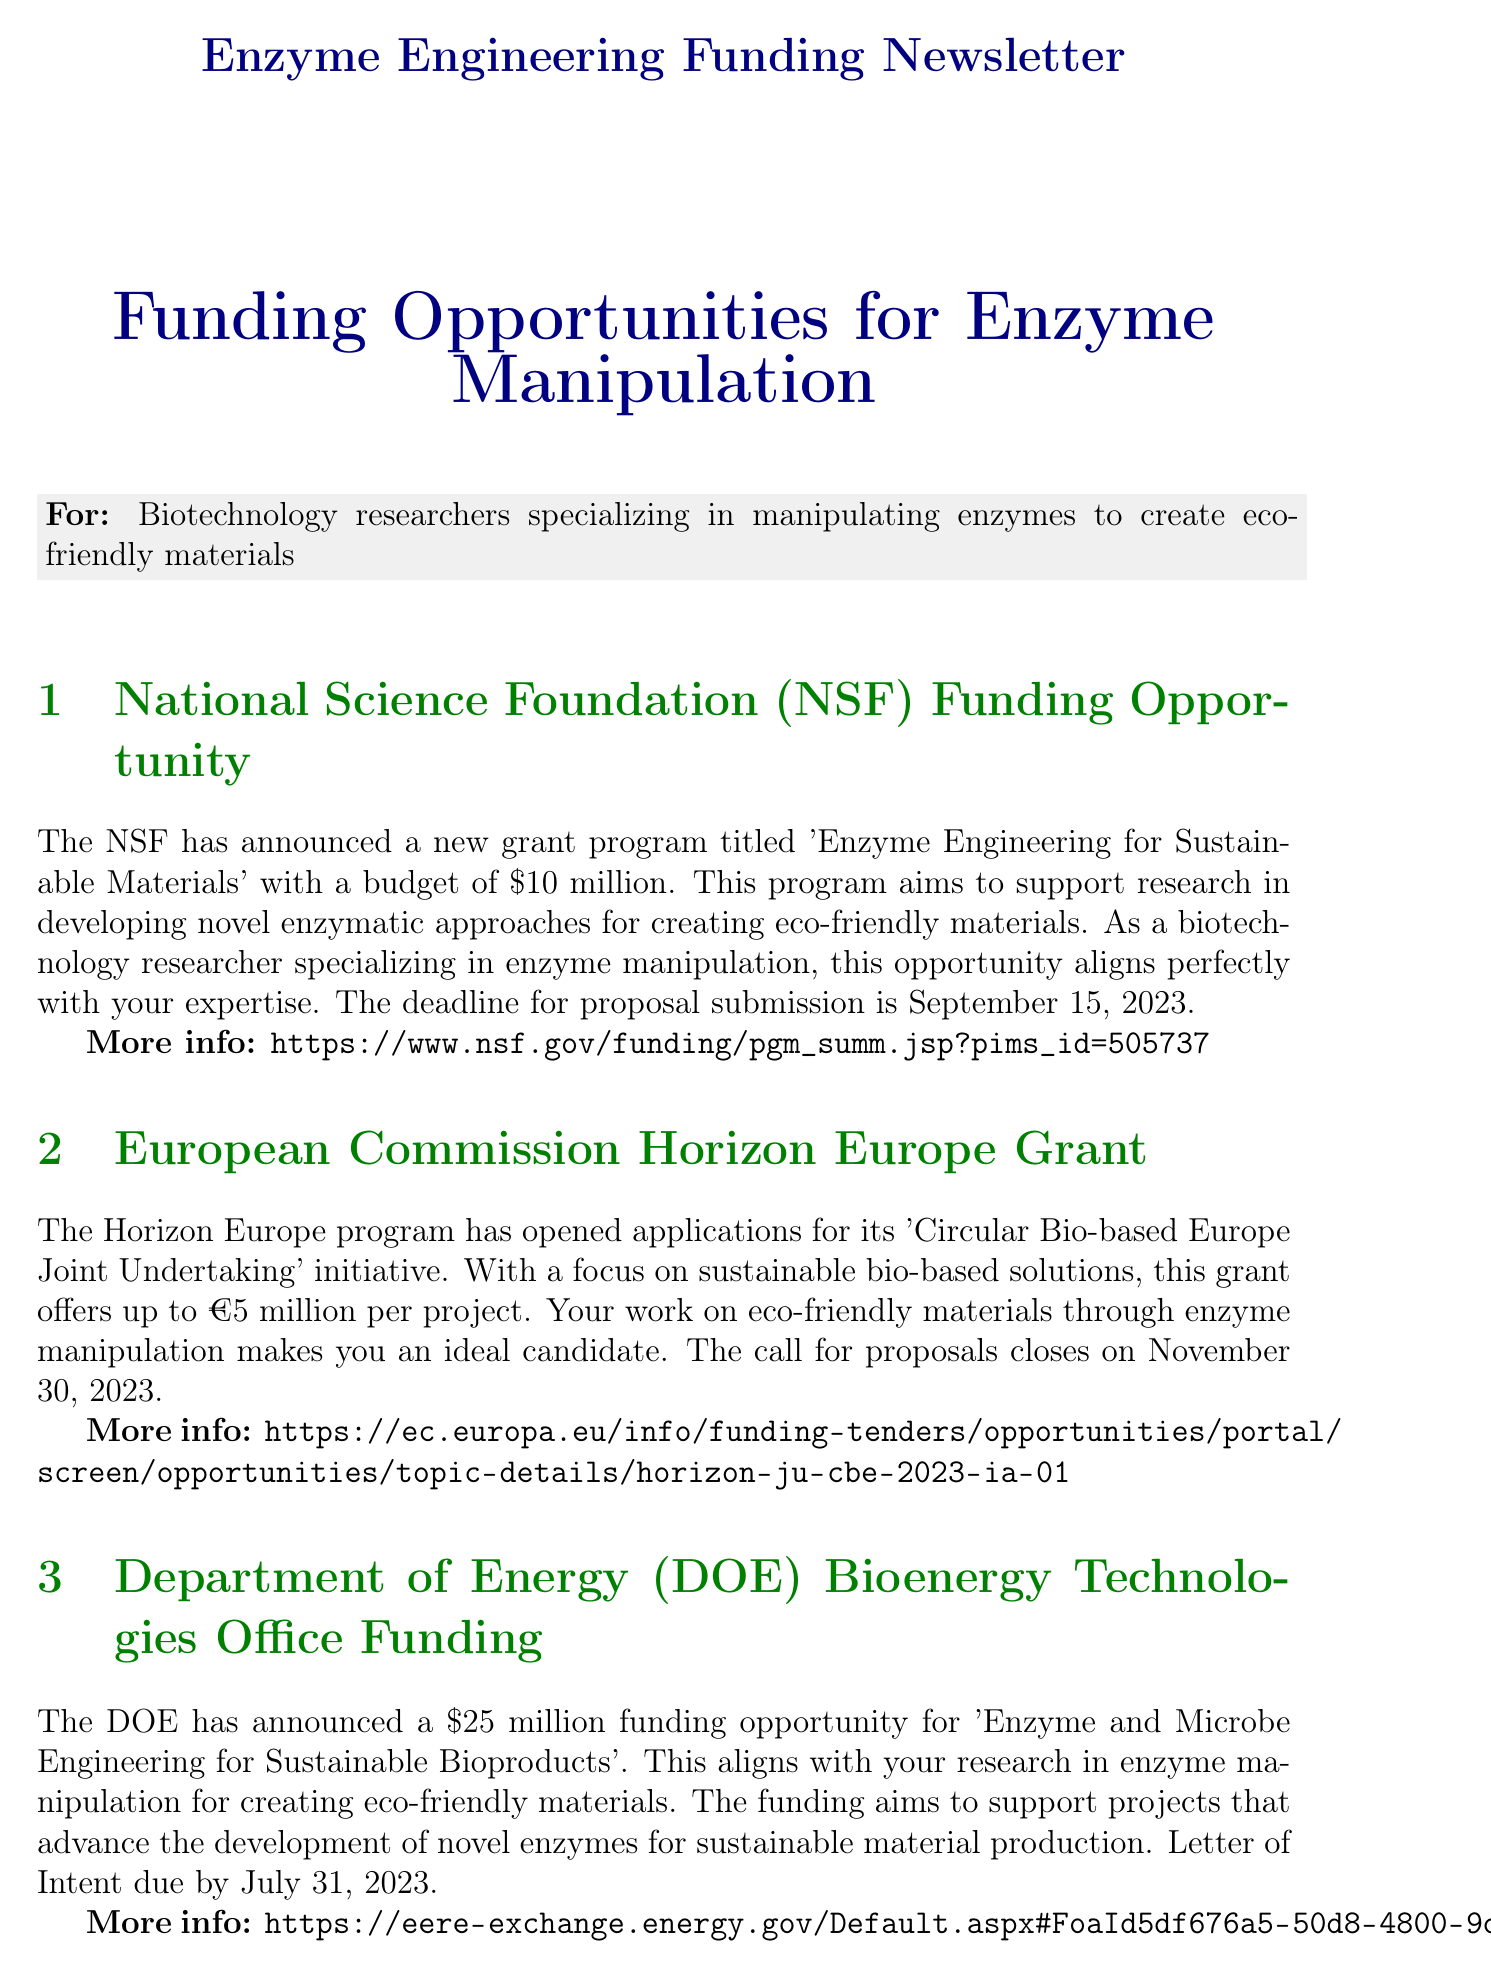What is the budget for the NSF grant program? The NSF grant program titled 'Enzyme Engineering for Sustainable Materials' has a budget of $10 million.
Answer: $10 million What is the deadline for the Department of Energy funding? The deadline for the Department of Energy funding opportunity is given as July 31, 2023.
Answer: July 31, 2023 How much funding does the Horizon Europe program offer per project? The Horizon Europe program offers up to €5 million per project.
Answer: €5 million What is the application deadline for the BASF-Novozymes Innovation Grant? The application deadline for the BASF-Novozymes Innovation Grant is October 1, 2023.
Answer: October 1, 2023 What is the main focus of the Bill & Melinda Gates Foundation Grand Challenges initiative? The main focus of this initiative is 'Sustainable Materials for Global Health', seeking innovative approaches for developing eco-friendly materials.
Answer: Sustainable Materials for Global Health What type of event is scheduled for November 15-17, 2023? The event scheduled for this date is the 5th Annual Enzymes in Sustainable Materials Summit.
Answer: 5th Annual Enzymes in Sustainable Materials Summit Which organization has partnered with Novozymes for an innovation grant? BASF has partnered with Novozymes to offer the innovation grant.
Answer: BASF What is the total amount of funding announced by the Department of Energy? The total funding amount announced by the Department of Energy is $25 million.
Answer: $25 million What is the pre-proposal submission due date for the Gates Foundation initiative? The pre-proposal submissions are due by August 31, 2023.
Answer: August 31, 2023 